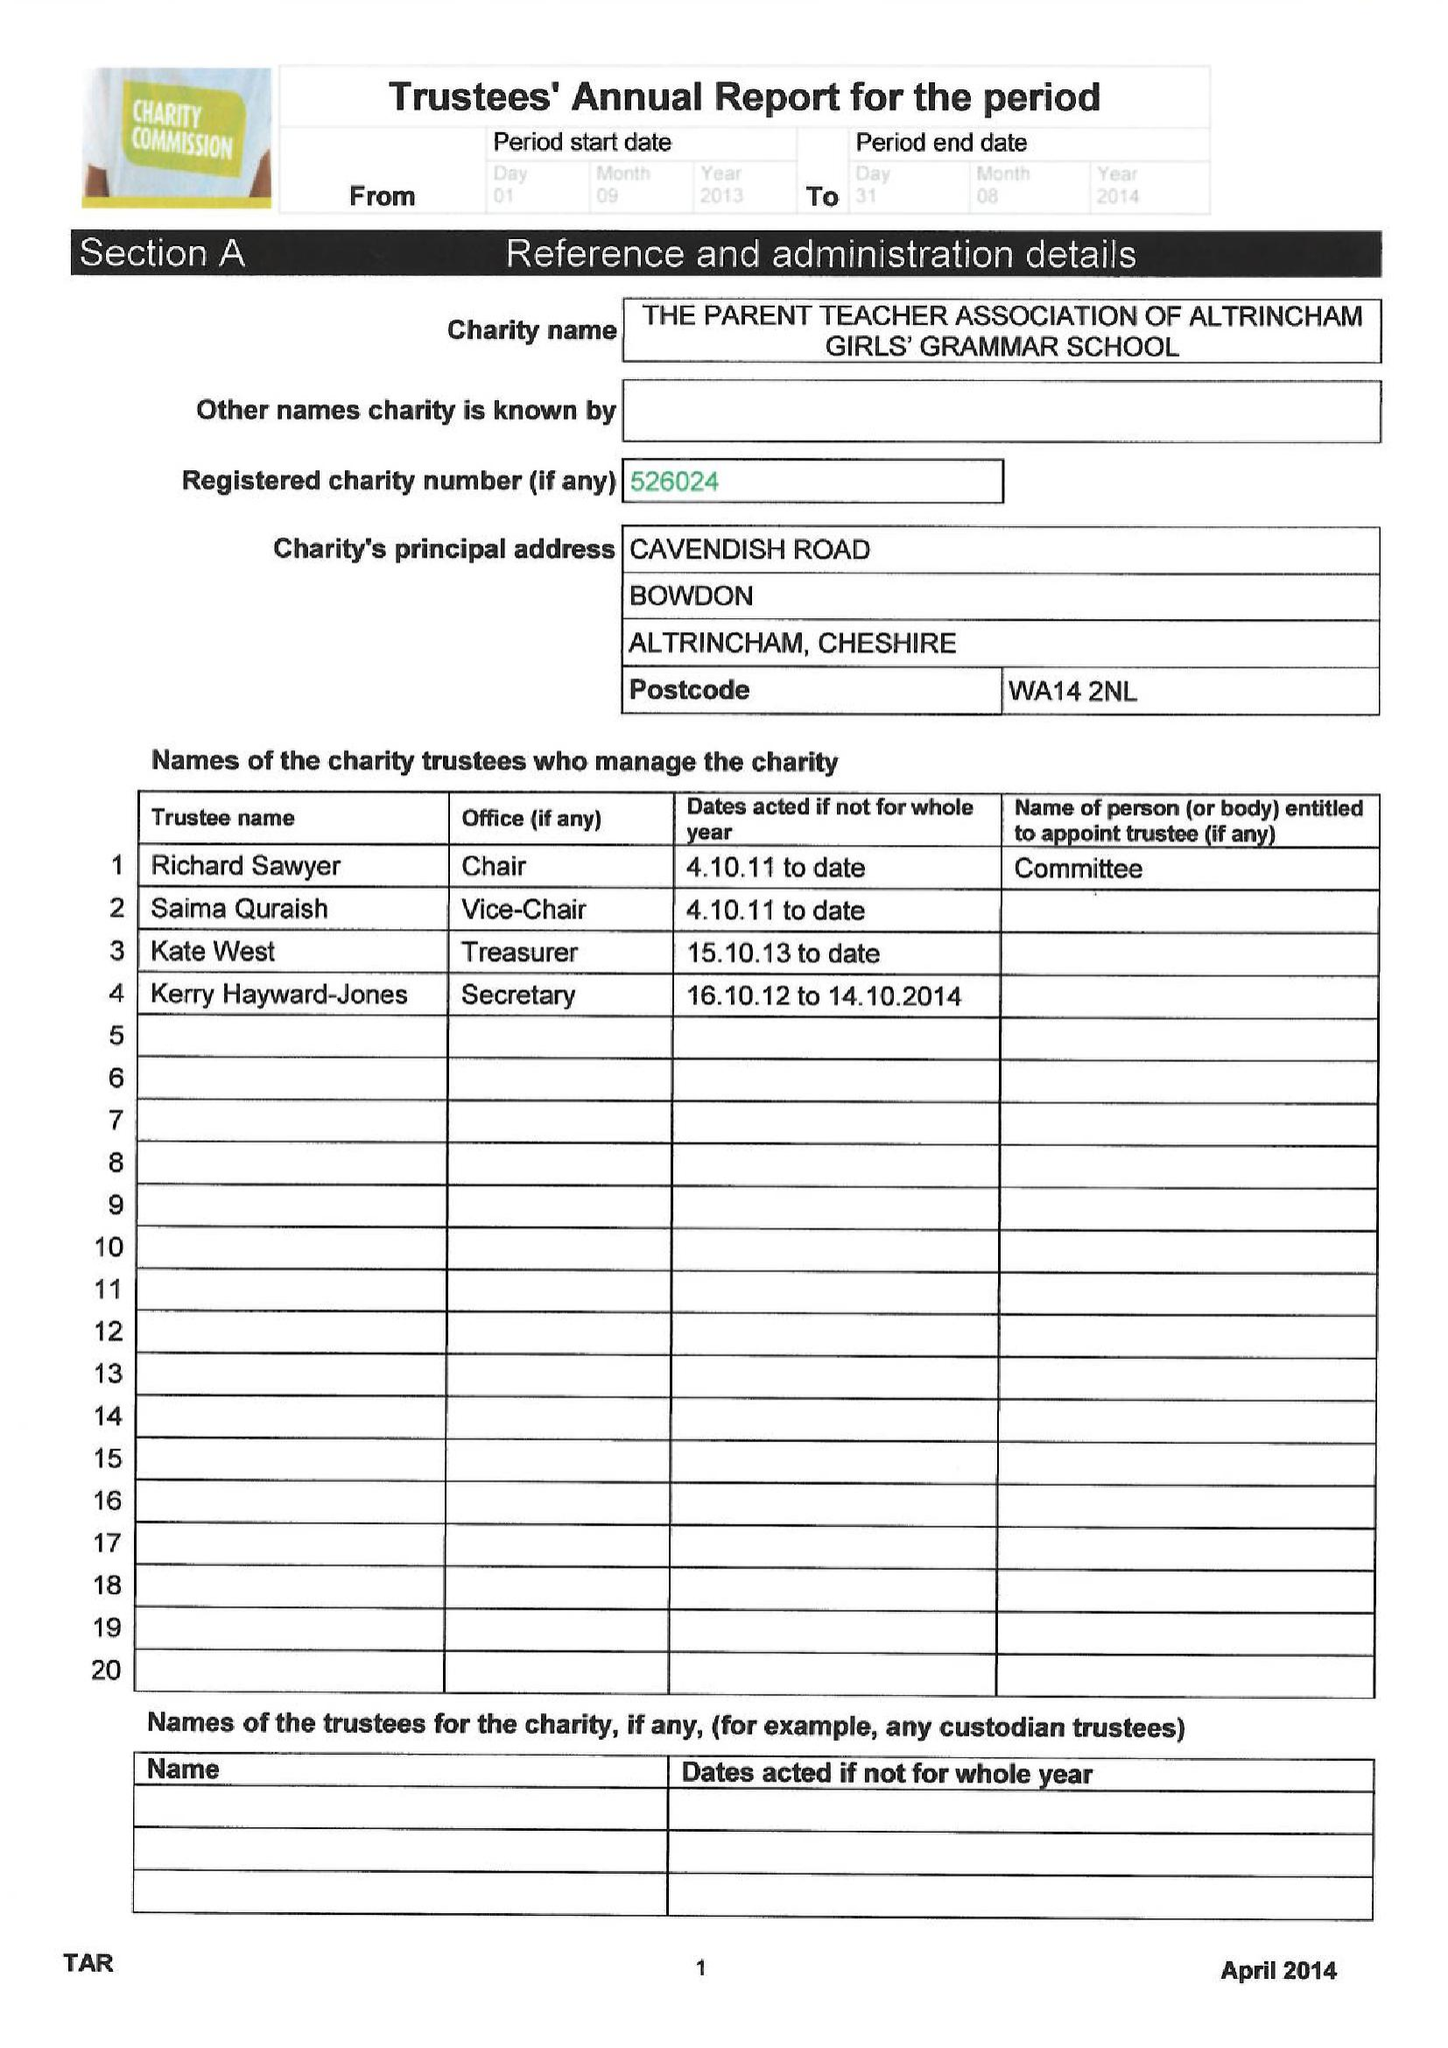What is the value for the report_date?
Answer the question using a single word or phrase. 2014-08-31 